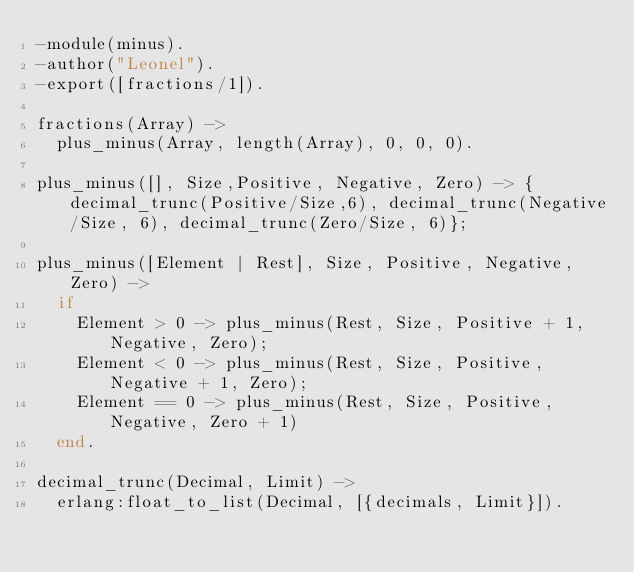<code> <loc_0><loc_0><loc_500><loc_500><_Erlang_>-module(minus).
-author("Leonel").
-export([fractions/1]).

fractions(Array) ->
  plus_minus(Array, length(Array), 0, 0, 0).

plus_minus([], Size,Positive, Negative, Zero) -> {decimal_trunc(Positive/Size,6), decimal_trunc(Negative/Size, 6), decimal_trunc(Zero/Size, 6)};

plus_minus([Element | Rest], Size, Positive, Negative, Zero) ->
  if 
    Element > 0 -> plus_minus(Rest, Size, Positive + 1, Negative, Zero);
    Element < 0 -> plus_minus(Rest, Size, Positive, Negative + 1, Zero);
    Element == 0 -> plus_minus(Rest, Size, Positive, Negative, Zero + 1)
  end.

decimal_trunc(Decimal, Limit) ->
  erlang:float_to_list(Decimal, [{decimals, Limit}]).
</code> 